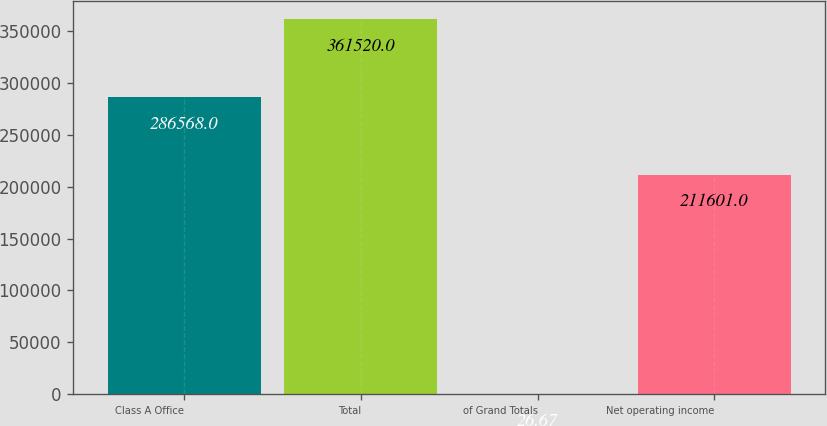Convert chart to OTSL. <chart><loc_0><loc_0><loc_500><loc_500><bar_chart><fcel>Class A Office<fcel>Total<fcel>of Grand Totals<fcel>Net operating income<nl><fcel>286568<fcel>361520<fcel>26.67<fcel>211601<nl></chart> 